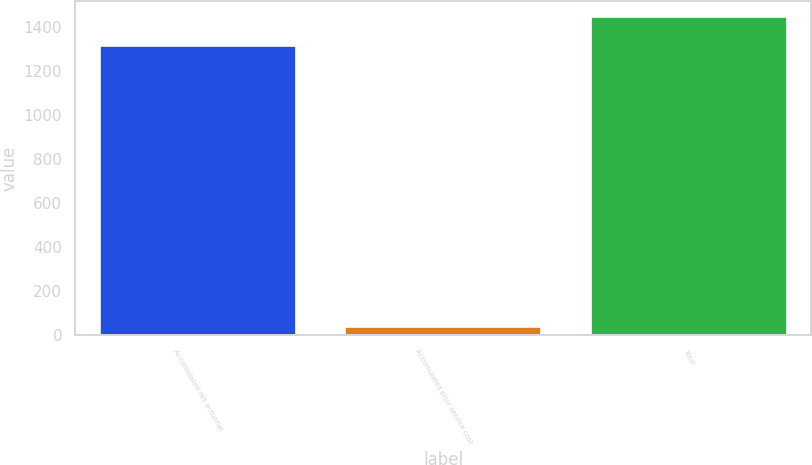Convert chart. <chart><loc_0><loc_0><loc_500><loc_500><bar_chart><fcel>Accumulated net actuarial<fcel>Accumulated prior service cost<fcel>Total<nl><fcel>1313<fcel>37<fcel>1444.3<nl></chart> 